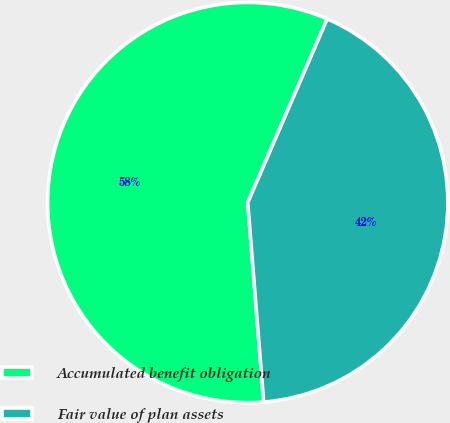<chart> <loc_0><loc_0><loc_500><loc_500><pie_chart><fcel>Accumulated benefit obligation<fcel>Fair value of plan assets<nl><fcel>57.77%<fcel>42.23%<nl></chart> 